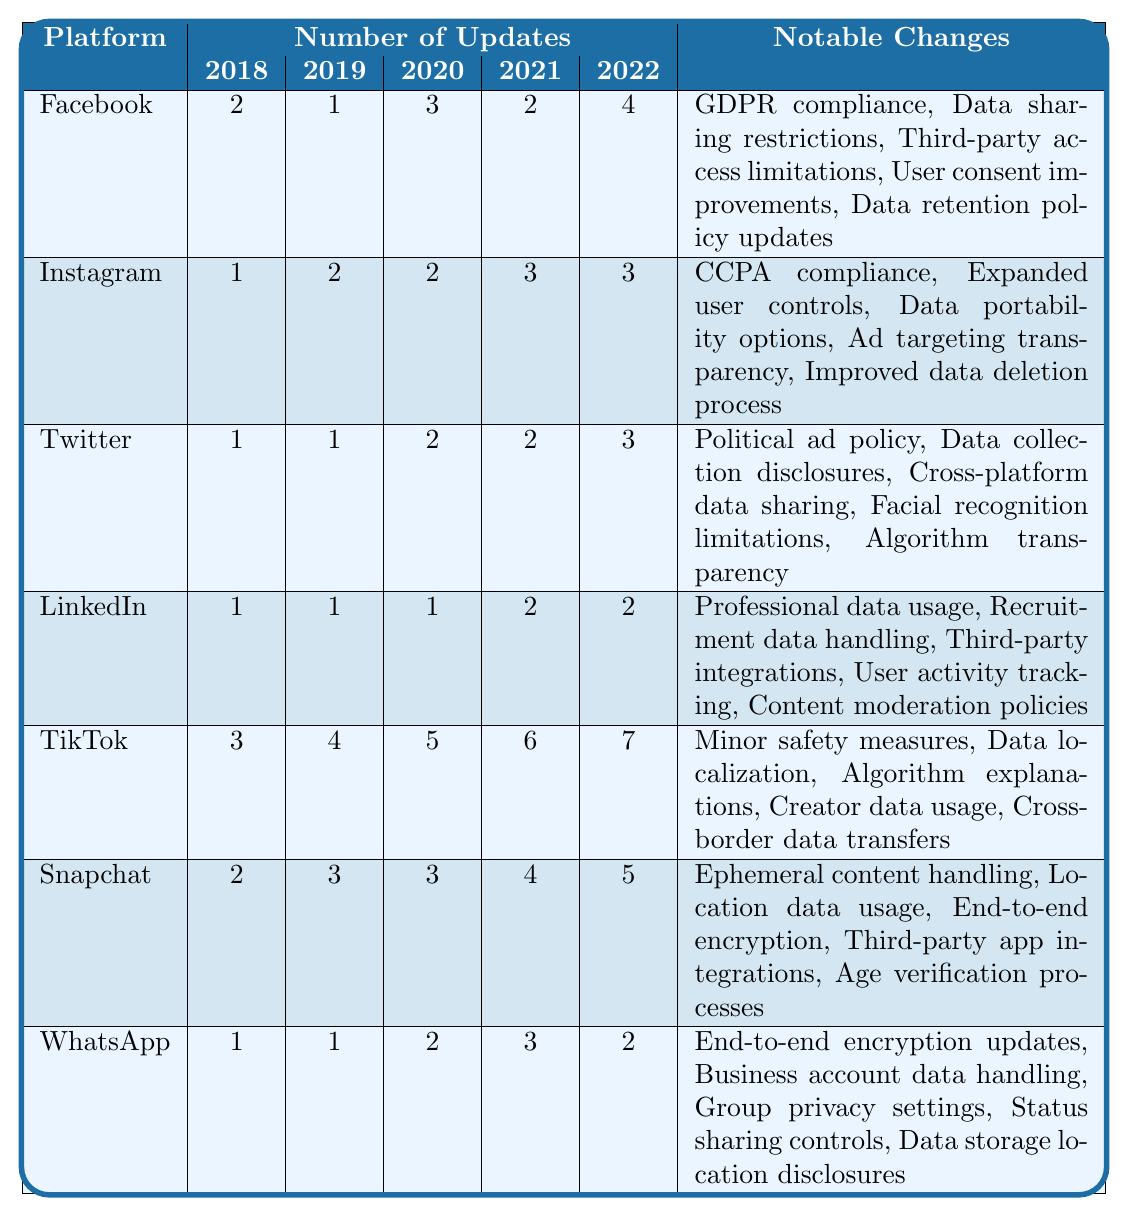What social media platform had the highest number of privacy policy updates in 2022? By looking at the 2022 column, TikTok has 7 updates, which is the highest among all platforms listed.
Answer: TikTok Which platform had the least number of updates in 2019? The 2019 column shows that Facebook had only 1 update, the least of all platforms.
Answer: Facebook What is the total number of updates made by Snapchat from 2018 to 2022? Adding Snapchat's updates: 2 + 3 + 3 + 4 + 5 equals 17 total updates over the five years.
Answer: 17 Did LinkedIn comply with any privacy regulations in its updates? LinkedIn's notable changes do not mention any specific compliance with privacy regulations. Therefore, the answer is no.
Answer: No Which platform had a consistent number of updates across the first three years from 2018 to 2020? LinkedIn shows 1 update for 2018, 1 for 2019, and again 1 for 2020, consistent across the first three years.
Answer: LinkedIn What was the average number of updates for Instagram over the years 2018 to 2022? Instagram's updates are (1 + 2 + 2 + 3 + 3) = 11; dividing this by 5 years gives an average of 2.2 updates per year.
Answer: 2.2 Which platform saw the highest increase in updates from 2021 to 2022? In 2021, TikTok had 6 updates, and in 2022 it increased to 7, which is an increase of 1. Snapchat also increased from 4 to 5. So, both TikTok and Snapchat had the same increase of 1.
Answer: TikTok and Snapchat What notable change did Facebook implement in its latest update in 2022? Among the notable changes listed for Facebook, a change mentioned in 2022 includes data retention policy updates.
Answer: Data retention policy updates Which platform had the most notable changes listed? TikTok has five notable changes listed, the highest among all the platforms.
Answer: TikTok Is there a platform that consistently had fewer updates than WhatsApp over the five years? Yes, LinkedIn had 1 update consistently for the first three years and then 2 in 2021 and 2022, which are fewer than WhatsApp’s updates in those years.
Answer: Yes 